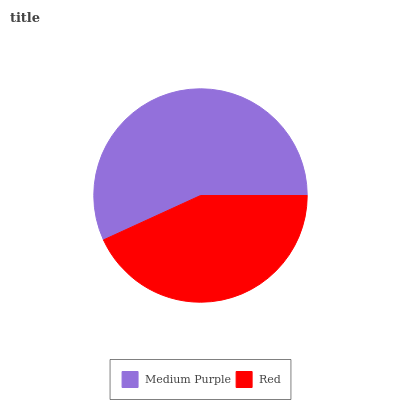Is Red the minimum?
Answer yes or no. Yes. Is Medium Purple the maximum?
Answer yes or no. Yes. Is Red the maximum?
Answer yes or no. No. Is Medium Purple greater than Red?
Answer yes or no. Yes. Is Red less than Medium Purple?
Answer yes or no. Yes. Is Red greater than Medium Purple?
Answer yes or no. No. Is Medium Purple less than Red?
Answer yes or no. No. Is Medium Purple the high median?
Answer yes or no. Yes. Is Red the low median?
Answer yes or no. Yes. Is Red the high median?
Answer yes or no. No. Is Medium Purple the low median?
Answer yes or no. No. 